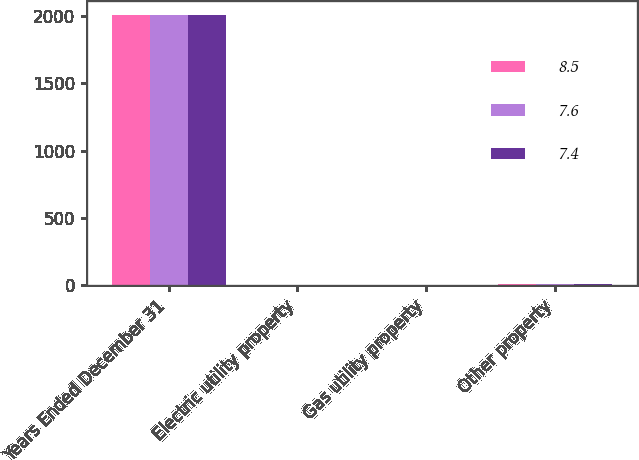Convert chart to OTSL. <chart><loc_0><loc_0><loc_500><loc_500><stacked_bar_chart><ecel><fcel>Years Ended December 31<fcel>Electric utility property<fcel>Gas utility property<fcel>Other property<nl><fcel>8.5<fcel>2010<fcel>3<fcel>2.9<fcel>7.4<nl><fcel>7.6<fcel>2009<fcel>3<fcel>2.9<fcel>7.6<nl><fcel>7.4<fcel>2008<fcel>3<fcel>3.6<fcel>8.5<nl></chart> 